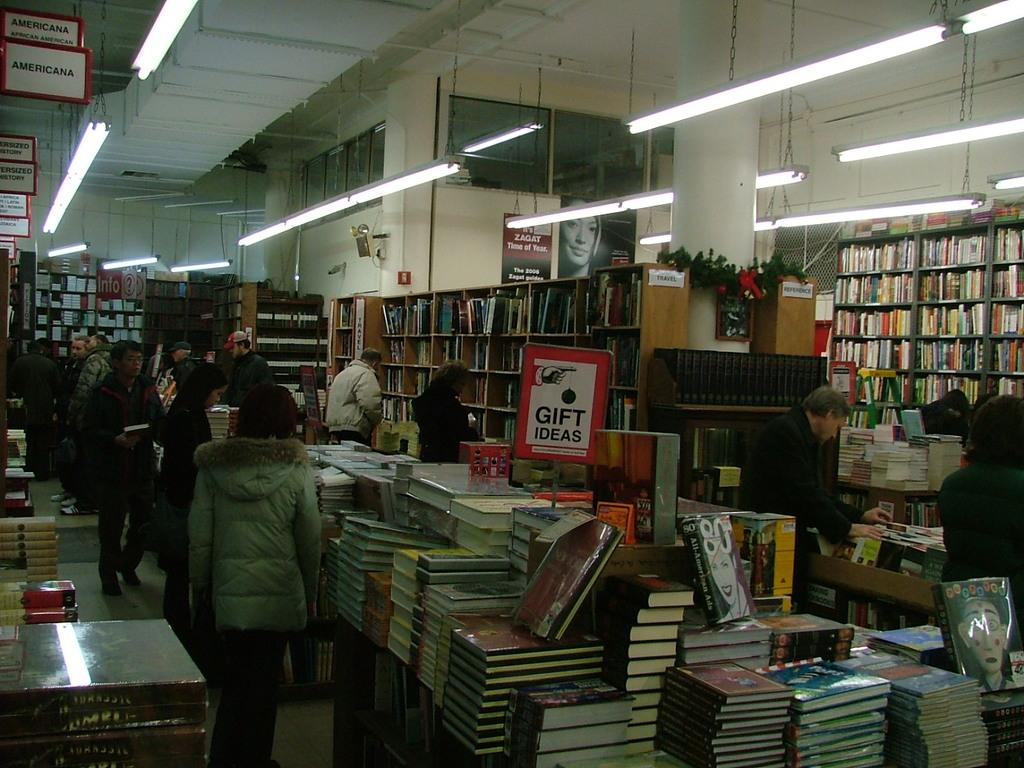Provide a one-sentence caption for the provided image. The closest section of books is for Americana. 